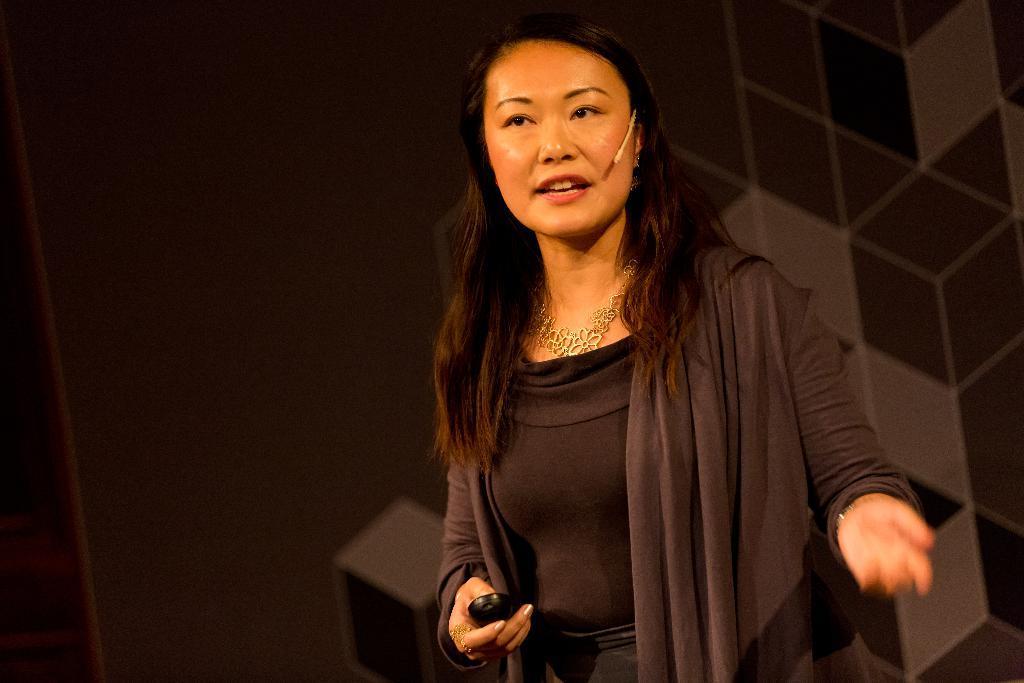Could you give a brief overview of what you see in this image? In this picture we can see a woman is standing and speaking something, it looks like a remote in her hand, there is a dark background. 